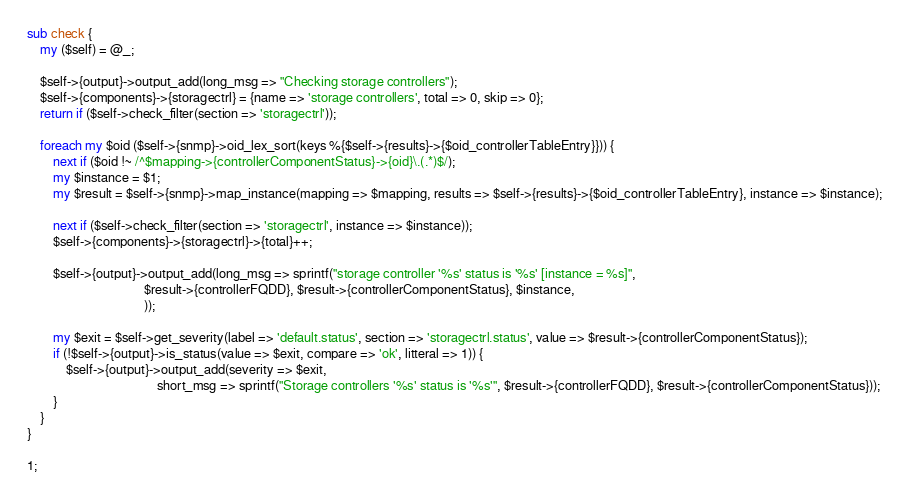<code> <loc_0><loc_0><loc_500><loc_500><_Perl_>
sub check {
    my ($self) = @_;

    $self->{output}->output_add(long_msg => "Checking storage controllers");
    $self->{components}->{storagectrl} = {name => 'storage controllers', total => 0, skip => 0};
    return if ($self->check_filter(section => 'storagectrl'));

    foreach my $oid ($self->{snmp}->oid_lex_sort(keys %{$self->{results}->{$oid_controllerTableEntry}})) {
        next if ($oid !~ /^$mapping->{controllerComponentStatus}->{oid}\.(.*)$/);
        my $instance = $1;
        my $result = $self->{snmp}->map_instance(mapping => $mapping, results => $self->{results}->{$oid_controllerTableEntry}, instance => $instance);
        
        next if ($self->check_filter(section => 'storagectrl', instance => $instance));
        $self->{components}->{storagectrl}->{total}++;

        $self->{output}->output_add(long_msg => sprintf("storage controller '%s' status is '%s' [instance = %s]",
                                    $result->{controllerFQDD}, $result->{controllerComponentStatus}, $instance, 
                                    ));

        my $exit = $self->get_severity(label => 'default.status', section => 'storagectrl.status', value => $result->{controllerComponentStatus});
        if (!$self->{output}->is_status(value => $exit, compare => 'ok', litteral => 1)) {
            $self->{output}->output_add(severity => $exit,
                                        short_msg => sprintf("Storage controllers '%s' status is '%s'", $result->{controllerFQDD}, $result->{controllerComponentStatus}));
        }
    }
}

1;</code> 